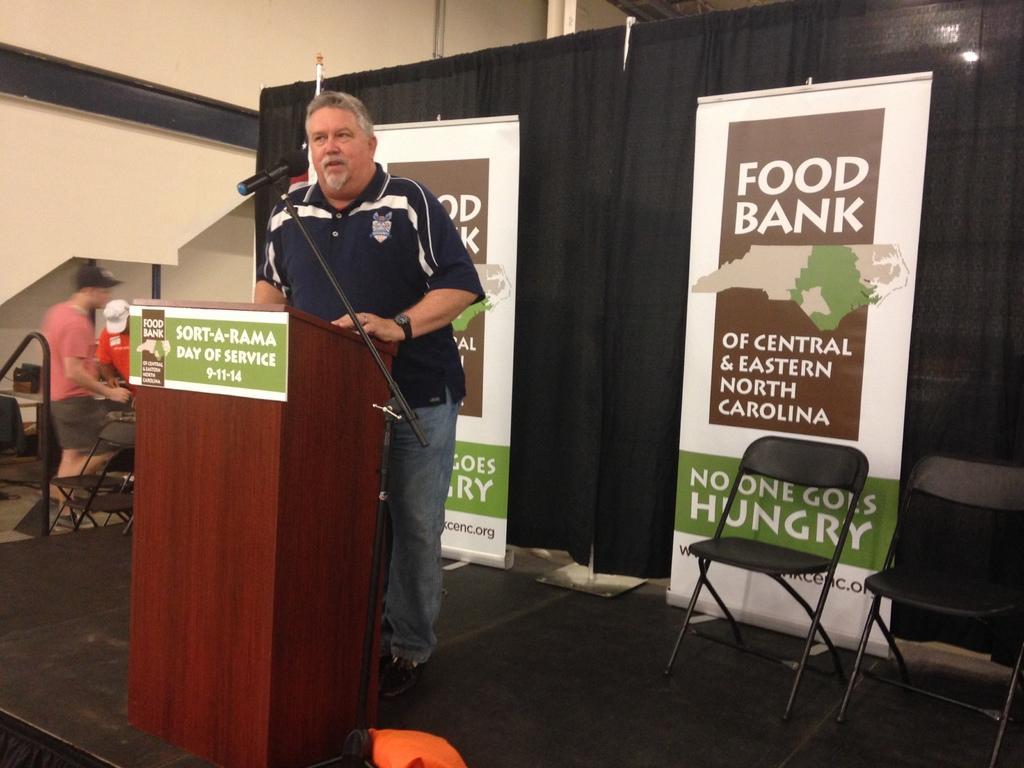Please provide a concise description of this image. In this image a person wearing a blue shirt is standing behind a podium having a mike stand beside it. Podium is on the stage having few banners and chairs on it. Beside the stage there are few chairs and few persons are standing on the floor. Behind them there is wall. 